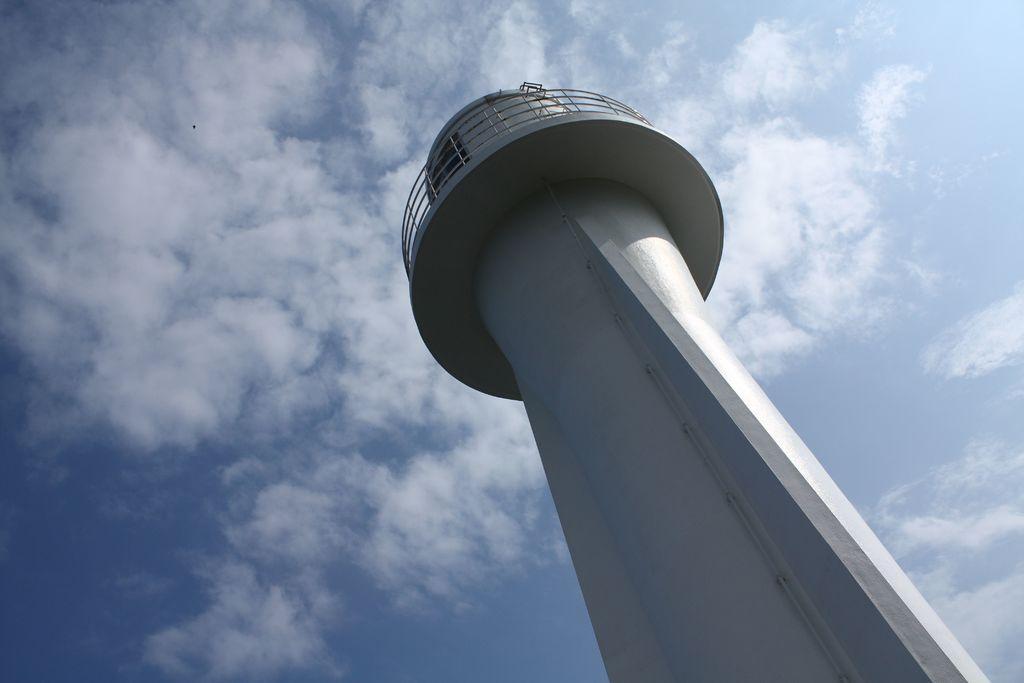In one or two sentences, can you explain what this image depicts? The picture consists of a building in the shape of a tower. Sky is sunny. The tower is painted white. 